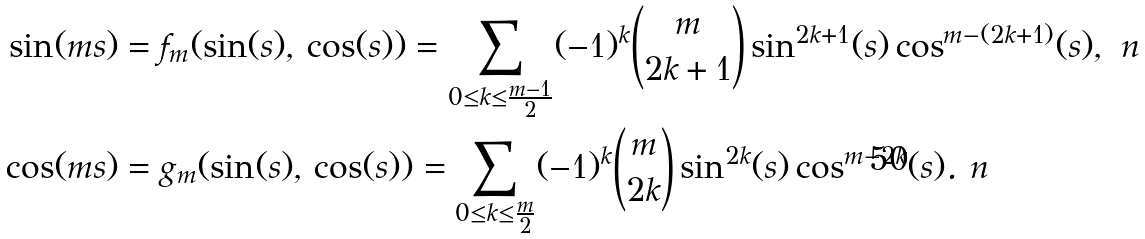Convert formula to latex. <formula><loc_0><loc_0><loc_500><loc_500>\sin ( m s ) & = f _ { m } ( \sin ( s ) , \, \cos ( s ) ) = \sum _ { 0 \leq k \leq \frac { m - 1 } { 2 } } ( - 1 ) ^ { k } { m \choose 2 k + 1 } \sin ^ { 2 k + 1 } ( s ) \cos ^ { m - ( 2 k + 1 ) } ( s ) , \ n \\ \cos ( m s ) & = g _ { m } ( \sin ( s ) , \, \cos ( s ) ) = \sum _ { 0 \leq k \leq \frac { m } { 2 } } ( - 1 ) ^ { k } { m \choose 2 k } \sin ^ { 2 k } ( s ) \cos ^ { m - 2 k } ( s ) . \ n</formula> 